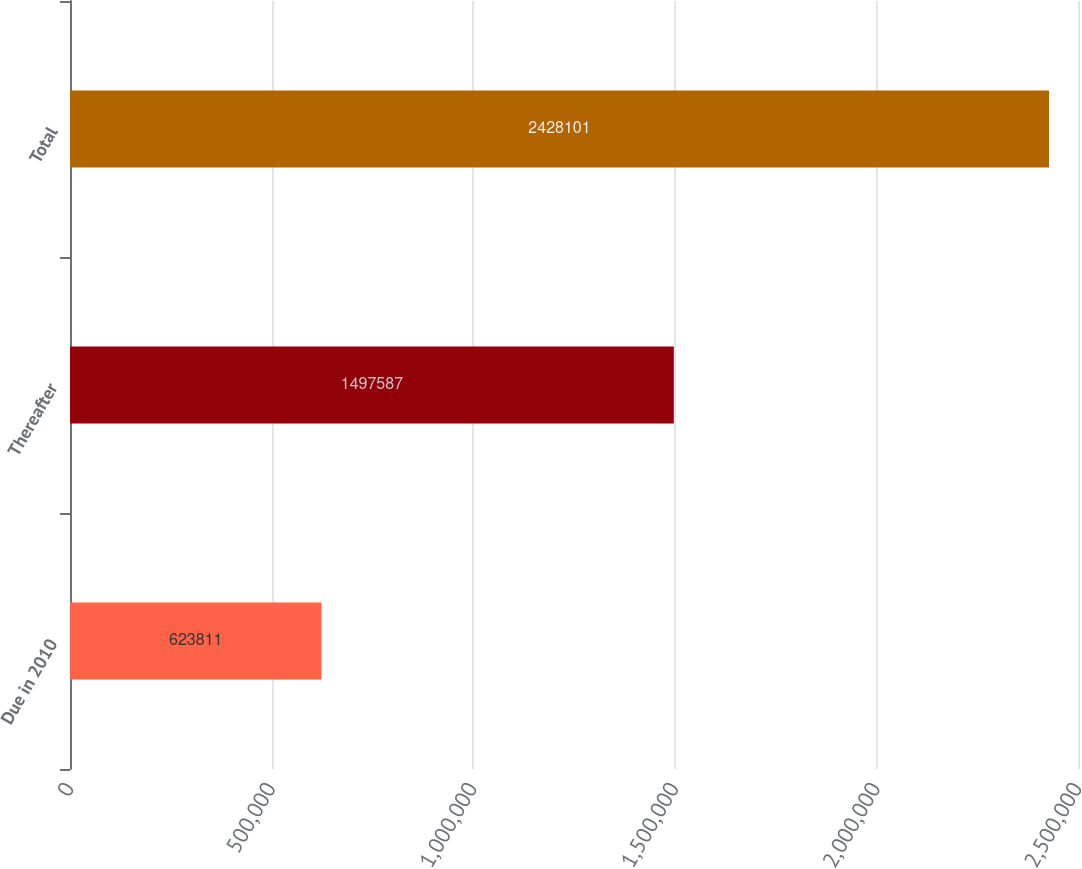Convert chart to OTSL. <chart><loc_0><loc_0><loc_500><loc_500><bar_chart><fcel>Due in 2010<fcel>Thereafter<fcel>Total<nl><fcel>623811<fcel>1.49759e+06<fcel>2.4281e+06<nl></chart> 